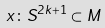Convert formula to latex. <formula><loc_0><loc_0><loc_500><loc_500>x \colon S ^ { 2 k + 1 } \subset M</formula> 